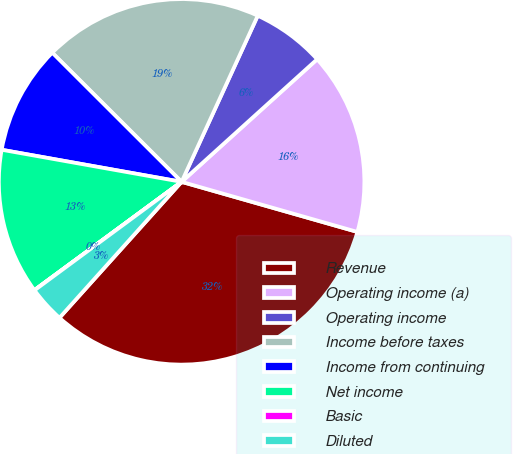Convert chart. <chart><loc_0><loc_0><loc_500><loc_500><pie_chart><fcel>Revenue<fcel>Operating income (a)<fcel>Operating income<fcel>Income before taxes<fcel>Income from continuing<fcel>Net income<fcel>Basic<fcel>Diluted<nl><fcel>32.23%<fcel>16.12%<fcel>6.46%<fcel>19.35%<fcel>9.68%<fcel>12.9%<fcel>0.02%<fcel>3.24%<nl></chart> 